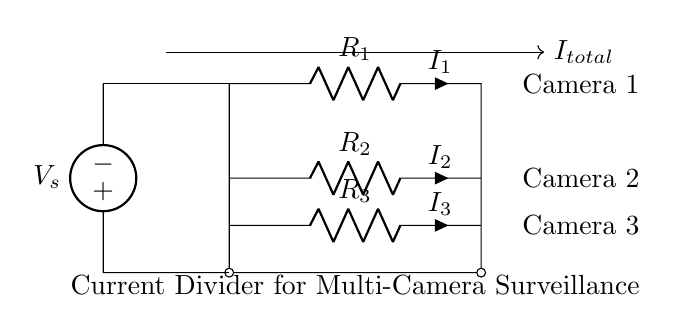What is the current flowing through Camera 1? The current flowing through Camera 1 is denoted by I1, which is shown next to the resistor R1 in the circuit.
Answer: I1 What are the components in this circuit? The components in the circuit include one voltage source and three resistors labeled R1, R2, and R3.
Answer: Voltage source, R1, R2, R3 What is the total current entering the circuit? The total current entering the circuit is represented as Itotal, which is indicated by the arrow pointing towards the cameras.
Answer: Itotal Which camera receives the highest current? To find which camera receives the highest current, we need to consider the resistance values (not given in the diagram), but generally, the camera connected to the lowest resistance would receive the highest current.
Answer: Camera with lowest resistance How does current splitting occur in this circuit? Current splitting occurs due to the different resistances of R1, R2, and R3; according to Kirchhoff's current law, the total current divides among the parallel branches inversely proportional to their resistances.
Answer: By resistance values What is the function of the voltage source in this circuit? The voltage source provides the necessary electrical potential to drive currents through the resistors, allowing each camera to operate as intended.
Answer: Provides electrical potential How can we determine the current through each camera? The currents through each camera can be determined using the current divider rule, which states that the current through a resistor in a parallel circuit is equal to the total current multiplied by the fraction of the other resistances in the circuit.
Answer: Current divider rule 